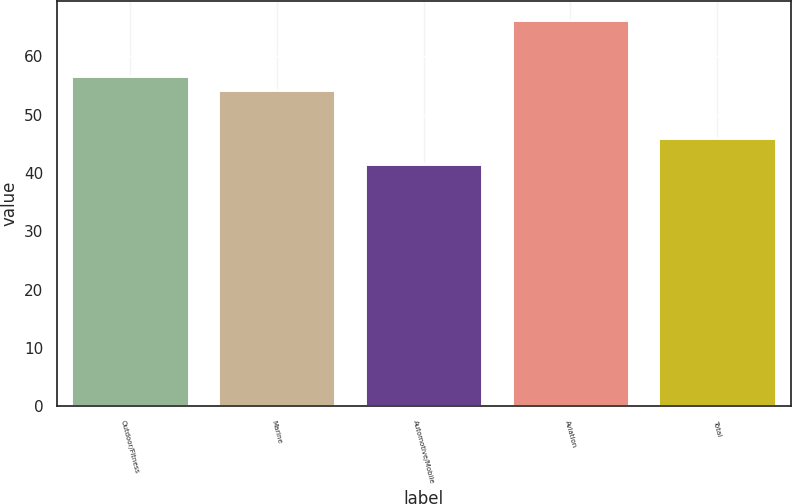<chart> <loc_0><loc_0><loc_500><loc_500><bar_chart><fcel>Outdoor/Fitness<fcel>Marine<fcel>Automotive/Mobile<fcel>Aviation<fcel>Total<nl><fcel>56.66<fcel>54.2<fcel>41.6<fcel>66.2<fcel>46<nl></chart> 